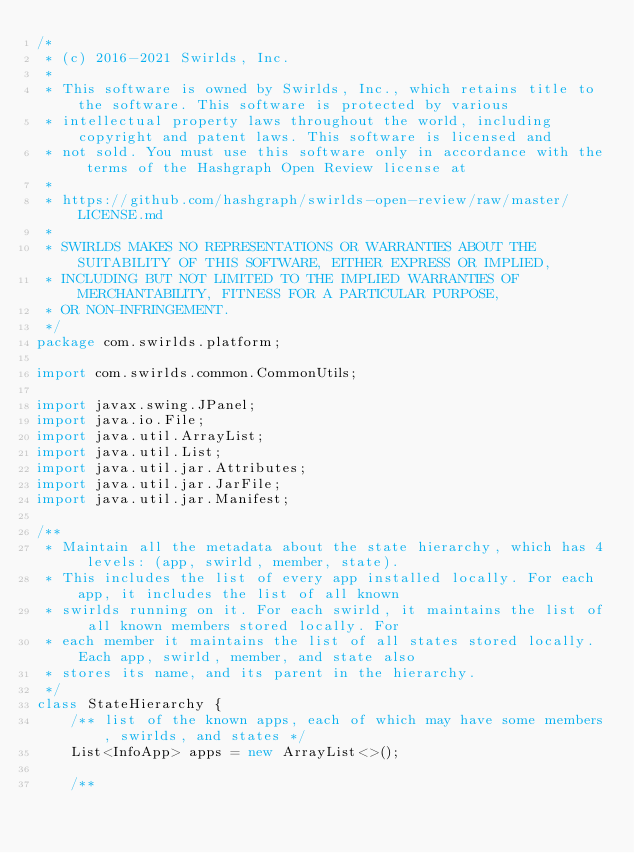<code> <loc_0><loc_0><loc_500><loc_500><_Java_>/*
 * (c) 2016-2021 Swirlds, Inc.
 *
 * This software is owned by Swirlds, Inc., which retains title to the software. This software is protected by various
 * intellectual property laws throughout the world, including copyright and patent laws. This software is licensed and
 * not sold. You must use this software only in accordance with the terms of the Hashgraph Open Review license at
 *
 * https://github.com/hashgraph/swirlds-open-review/raw/master/LICENSE.md
 *
 * SWIRLDS MAKES NO REPRESENTATIONS OR WARRANTIES ABOUT THE SUITABILITY OF THIS SOFTWARE, EITHER EXPRESS OR IMPLIED,
 * INCLUDING BUT NOT LIMITED TO THE IMPLIED WARRANTIES OF MERCHANTABILITY, FITNESS FOR A PARTICULAR PURPOSE,
 * OR NON-INFRINGEMENT.
 */
package com.swirlds.platform;

import com.swirlds.common.CommonUtils;

import javax.swing.JPanel;
import java.io.File;
import java.util.ArrayList;
import java.util.List;
import java.util.jar.Attributes;
import java.util.jar.JarFile;
import java.util.jar.Manifest;

/**
 * Maintain all the metadata about the state hierarchy, which has 4 levels: (app, swirld, member, state).
 * This includes the list of every app installed locally. For each app, it includes the list of all known
 * swirlds running on it. For each swirld, it maintains the list of all known members stored locally. For
 * each member it maintains the list of all states stored locally. Each app, swirld, member, and state also
 * stores its name, and its parent in the hierarchy.
 */
class StateHierarchy {
	/** list of the known apps, each of which may have some members, swirlds, and states */
	List<InfoApp> apps = new ArrayList<>();

	/**</code> 